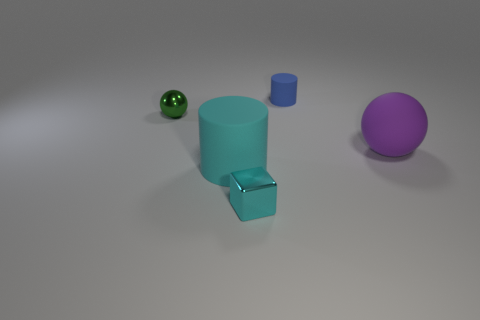What is the size of the cube that is the same color as the large rubber cylinder?
Make the answer very short. Small. There is a large cylinder that is the same color as the cube; what is it made of?
Make the answer very short. Rubber. There is a large thing to the left of the tiny cyan metal block; is it the same color as the block?
Provide a succinct answer. Yes. Do the big matte cylinder and the small metal object in front of the purple rubber ball have the same color?
Your answer should be compact. Yes. Is the color of the cube the same as the large cylinder?
Ensure brevity in your answer.  Yes. Is the number of tiny spheres right of the big cylinder less than the number of tiny blue rubber cylinders?
Give a very brief answer. Yes. There is a thing that is the same material as the cyan cube; what is its shape?
Offer a terse response. Sphere. What number of rubber balls are the same color as the small cylinder?
Your response must be concise. 0. How many objects are either cyan cubes or small green metal objects?
Provide a short and direct response. 2. The cylinder right of the shiny thing in front of the big purple rubber object is made of what material?
Offer a terse response. Rubber. 